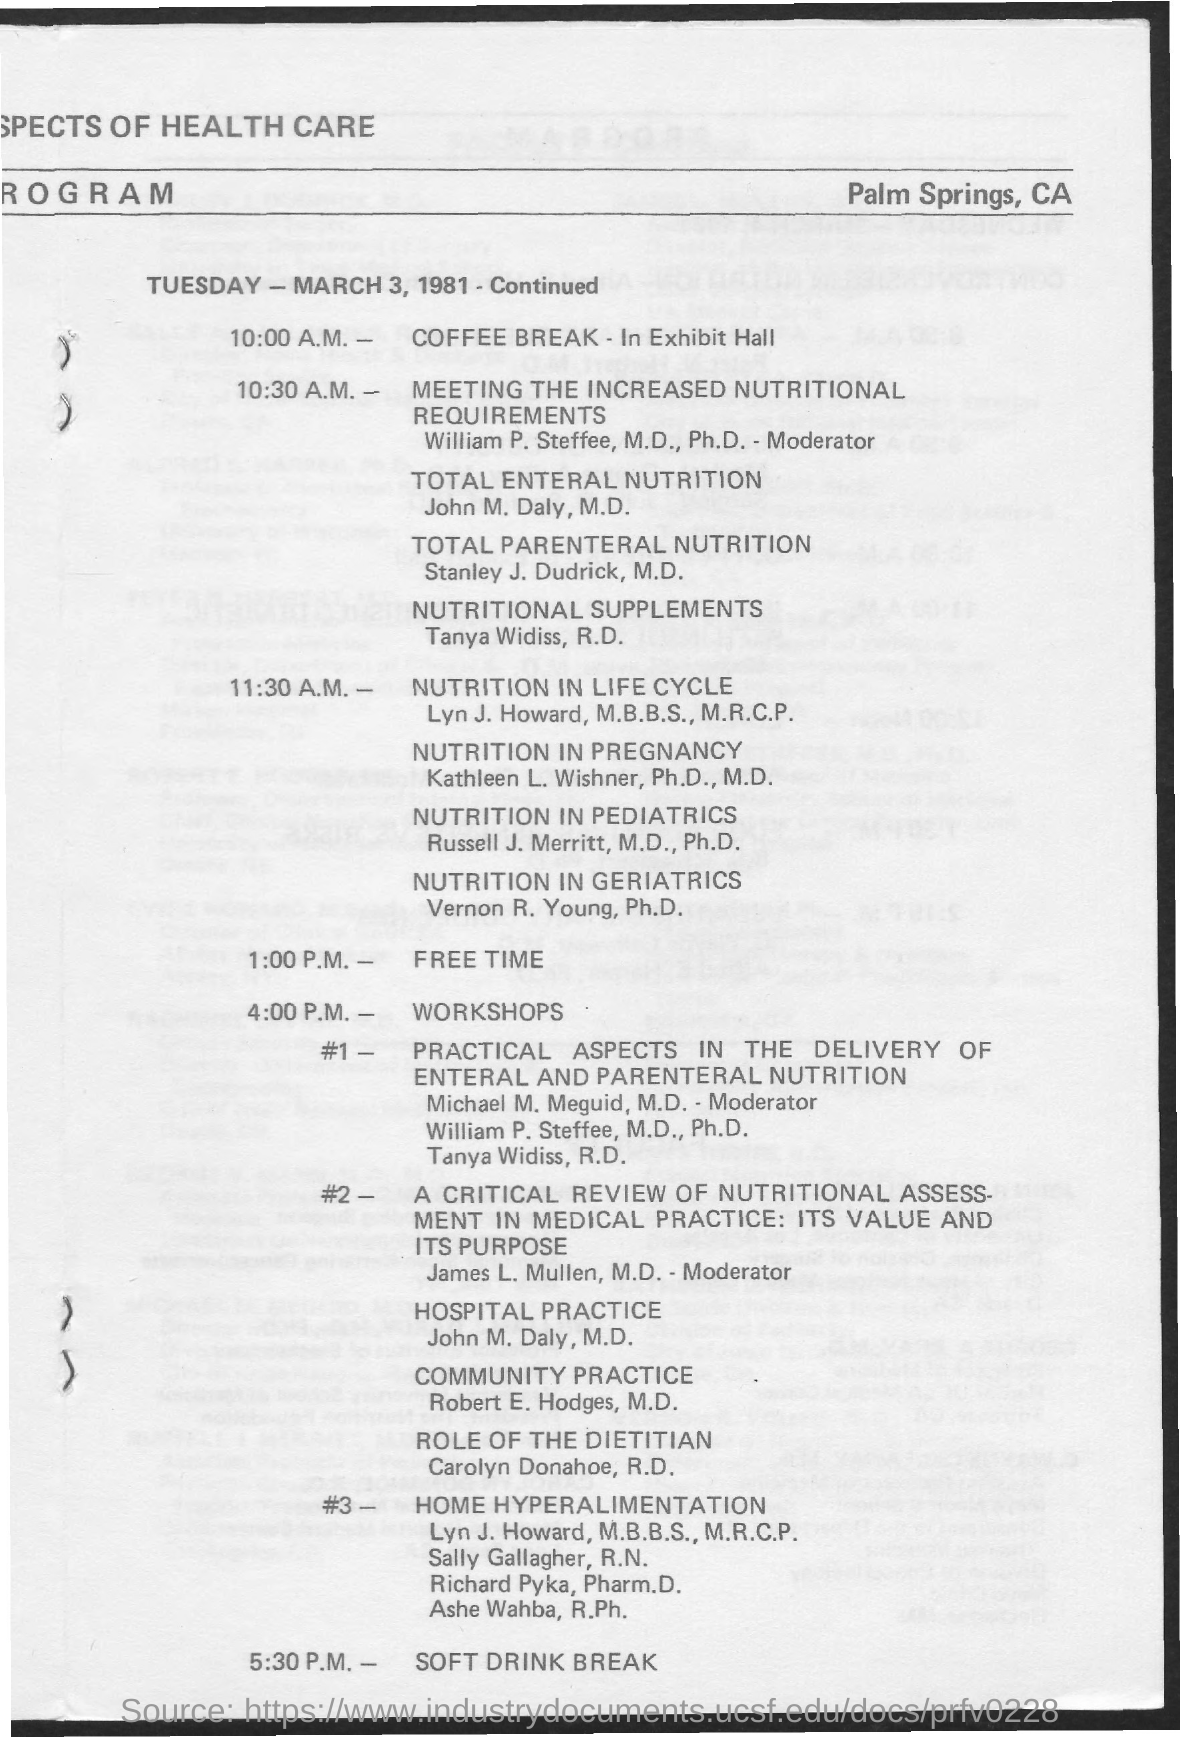Highlight a few significant elements in this photo. The event "NUTRITION IN LIFE CYCLE" will take place at 11:30 A.M... The coffee break will take place on Tuesday at 10:00 A.M. The designated time for the "SOFT DRINK BREAK" is 5:30 P.M. Free time, as mentioned, is scheduled for 1:00 p.m. The first workshop, titled "Practical Aspects in the Delivery of Enteral and Parenteral Nutrition," is on the topic of practical considerations in the administration of enteral and parenteral nutrition. 